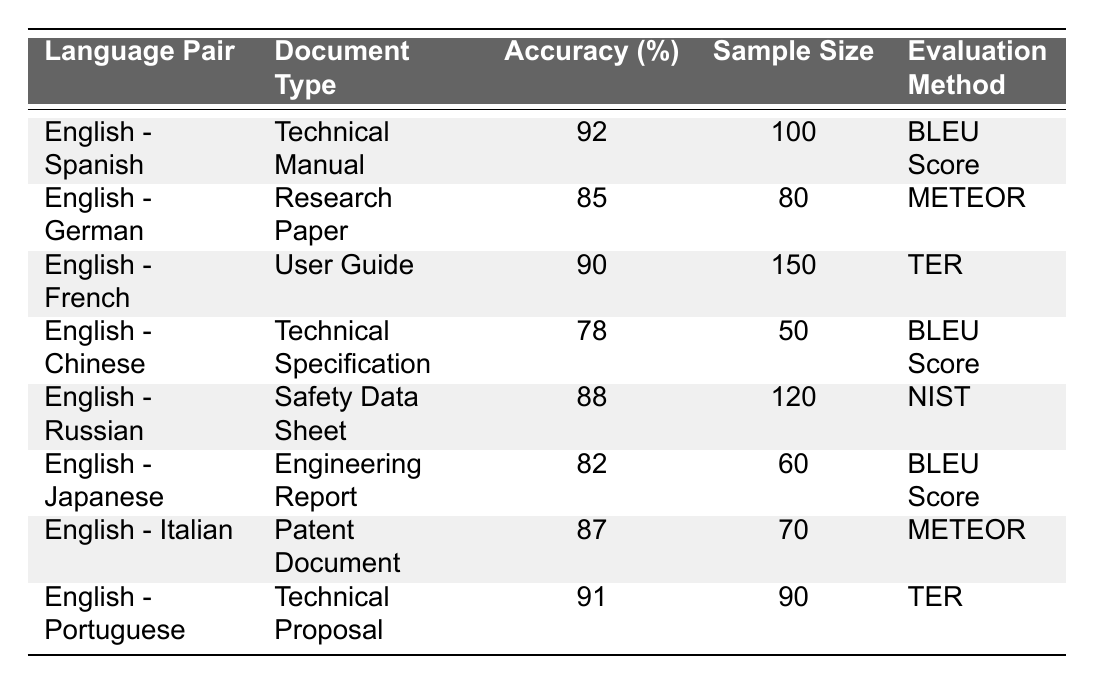What is the highest accuracy percentage among the translations? The table shows various accuracy percentages. Looking through the "Accuracy (%)" column, the highest value is 92 for the English-Spanish translation.
Answer: 92 Which language pair has the lowest accuracy percentage? By examining the "Accuracy (%)" column, the lowest value is 78, which is associated with the English-Chinese translation.
Answer: English - Chinese How many samples were evaluated for the English - Portuguese translation? In the "Sample Size" column for the English-Portuguese translation, it indicates a sample size of 90.
Answer: 90 What is the average accuracy percentage for all the translations provided? To calculate the average, sum the accuracy percentages: 92 + 85 + 90 + 78 + 88 + 82 + 87 + 91 = 713. There are 8 language pairs, so the average is 713/8 = 89.125.
Answer: 89.125 Which evaluation method was used for the highest accuracy translation? The highest accuracy translation is English - Spanish at 92%. Referring to the "Evaluation Method" column, it uses the BLEU Score method.
Answer: BLEU Score Is there any document type that has an accuracy percentage of 85%? Yes, checking the table shows that the English - German translation, which is a Research Paper, has an accuracy percentage of 85%.
Answer: Yes How does the accuracy of English - Russian compare to English - Japanese? The English - Russian translation has an accuracy of 88%, while the English - Japanese translation has an accuracy of 82%. Therefore, English - Russian is better by 6 percentage points.
Answer: 6 percentage points Which two language pairs have the same evaluation method? Looking at the table, both English - Italian and English - German translations use the METEOR evaluation method.
Answer: English - Italian and English - German How many technical document types were assessed in total? By reviewing the "Document Type" column, the table lists 8 different types of documents, which are unique and total to 8.
Answer: 8 Which translation has the highest sample size and what is the accuracy for that translation? The English - French translation has the highest sample size of 150, with an accuracy of 90%.
Answer: English - French, 90% 